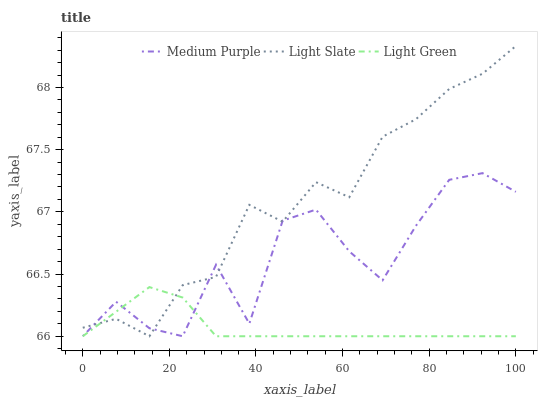Does Light Green have the minimum area under the curve?
Answer yes or no. Yes. Does Light Slate have the maximum area under the curve?
Answer yes or no. Yes. Does Light Slate have the minimum area under the curve?
Answer yes or no. No. Does Light Green have the maximum area under the curve?
Answer yes or no. No. Is Light Green the smoothest?
Answer yes or no. Yes. Is Medium Purple the roughest?
Answer yes or no. Yes. Is Light Slate the smoothest?
Answer yes or no. No. Is Light Slate the roughest?
Answer yes or no. No. Does Medium Purple have the lowest value?
Answer yes or no. Yes. Does Light Slate have the highest value?
Answer yes or no. Yes. Does Light Green have the highest value?
Answer yes or no. No. Does Medium Purple intersect Light Green?
Answer yes or no. Yes. Is Medium Purple less than Light Green?
Answer yes or no. No. Is Medium Purple greater than Light Green?
Answer yes or no. No. 